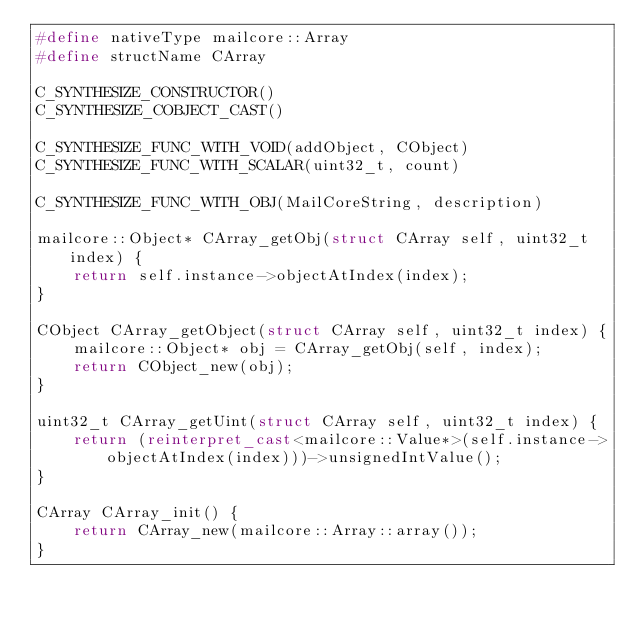Convert code to text. <code><loc_0><loc_0><loc_500><loc_500><_C++_>#define nativeType mailcore::Array
#define structName CArray

C_SYNTHESIZE_CONSTRUCTOR()
C_SYNTHESIZE_COBJECT_CAST()

C_SYNTHESIZE_FUNC_WITH_VOID(addObject, CObject)
C_SYNTHESIZE_FUNC_WITH_SCALAR(uint32_t, count)

C_SYNTHESIZE_FUNC_WITH_OBJ(MailCoreString, description)

mailcore::Object* CArray_getObj(struct CArray self, uint32_t index) {
    return self.instance->objectAtIndex(index);
}

CObject CArray_getObject(struct CArray self, uint32_t index) {
    mailcore::Object* obj = CArray_getObj(self, index);
    return CObject_new(obj);
}

uint32_t CArray_getUint(struct CArray self, uint32_t index) {
    return (reinterpret_cast<mailcore::Value*>(self.instance->objectAtIndex(index)))->unsignedIntValue();
}

CArray CArray_init() {
    return CArray_new(mailcore::Array::array());
}

</code> 